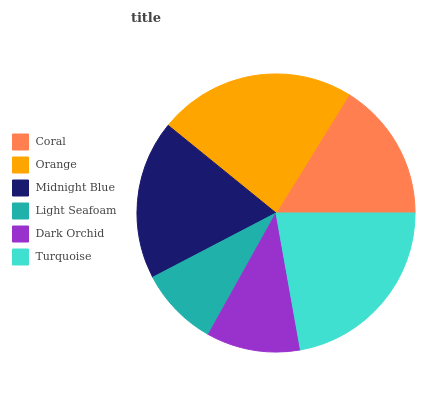Is Light Seafoam the minimum?
Answer yes or no. Yes. Is Orange the maximum?
Answer yes or no. Yes. Is Midnight Blue the minimum?
Answer yes or no. No. Is Midnight Blue the maximum?
Answer yes or no. No. Is Orange greater than Midnight Blue?
Answer yes or no. Yes. Is Midnight Blue less than Orange?
Answer yes or no. Yes. Is Midnight Blue greater than Orange?
Answer yes or no. No. Is Orange less than Midnight Blue?
Answer yes or no. No. Is Midnight Blue the high median?
Answer yes or no. Yes. Is Coral the low median?
Answer yes or no. Yes. Is Dark Orchid the high median?
Answer yes or no. No. Is Dark Orchid the low median?
Answer yes or no. No. 